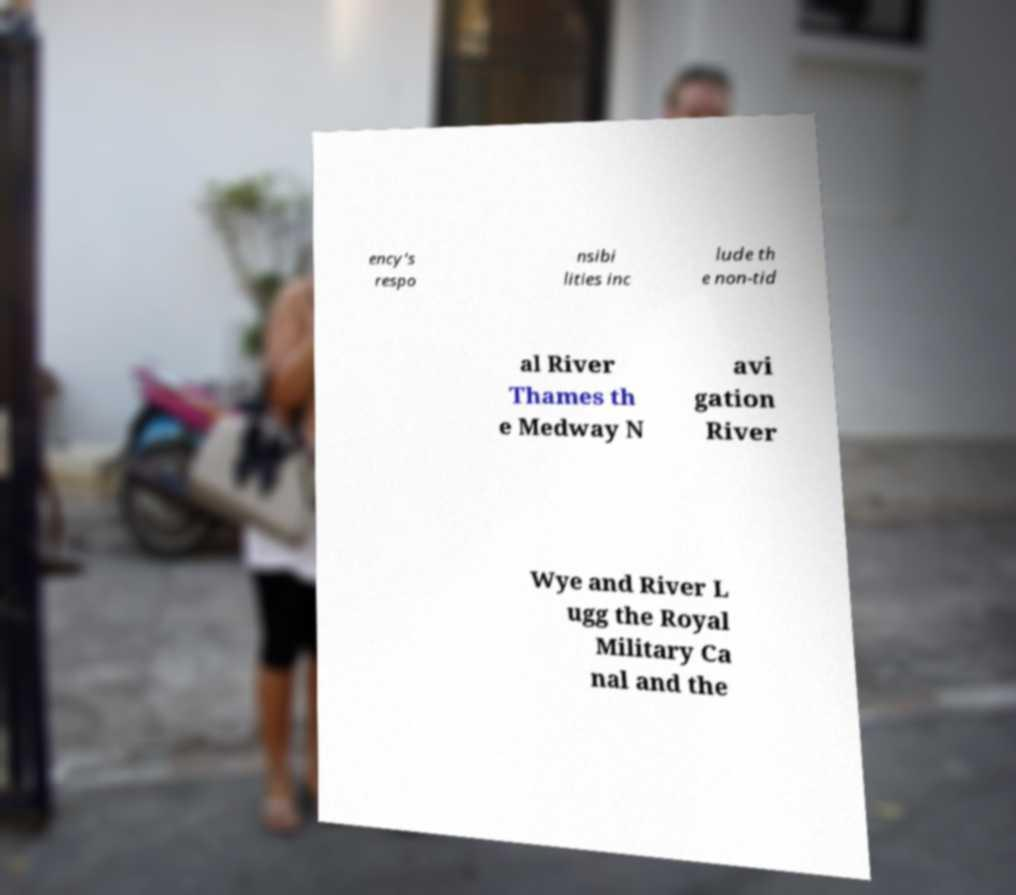For documentation purposes, I need the text within this image transcribed. Could you provide that? ency's respo nsibi lities inc lude th e non-tid al River Thames th e Medway N avi gation River Wye and River L ugg the Royal Military Ca nal and the 